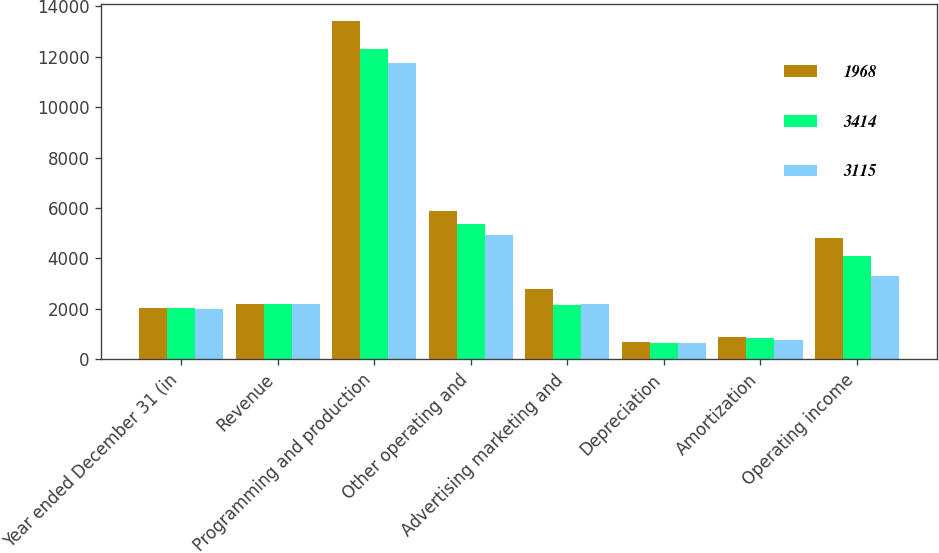Convert chart. <chart><loc_0><loc_0><loc_500><loc_500><stacked_bar_chart><ecel><fcel>Year ended December 31 (in<fcel>Revenue<fcel>Programming and production<fcel>Other operating and<fcel>Advertising marketing and<fcel>Depreciation<fcel>Amortization<fcel>Operating income<nl><fcel>1968<fcel>2015<fcel>2199<fcel>13418<fcel>5891<fcel>2795<fcel>669<fcel>870<fcel>4819<nl><fcel>3414<fcel>2014<fcel>2199<fcel>12318<fcel>5364<fcel>2158<fcel>654<fcel>841<fcel>4093<nl><fcel>3115<fcel>2013<fcel>2199<fcel>11770<fcel>4949<fcel>2199<fcel>639<fcel>772<fcel>3321<nl></chart> 